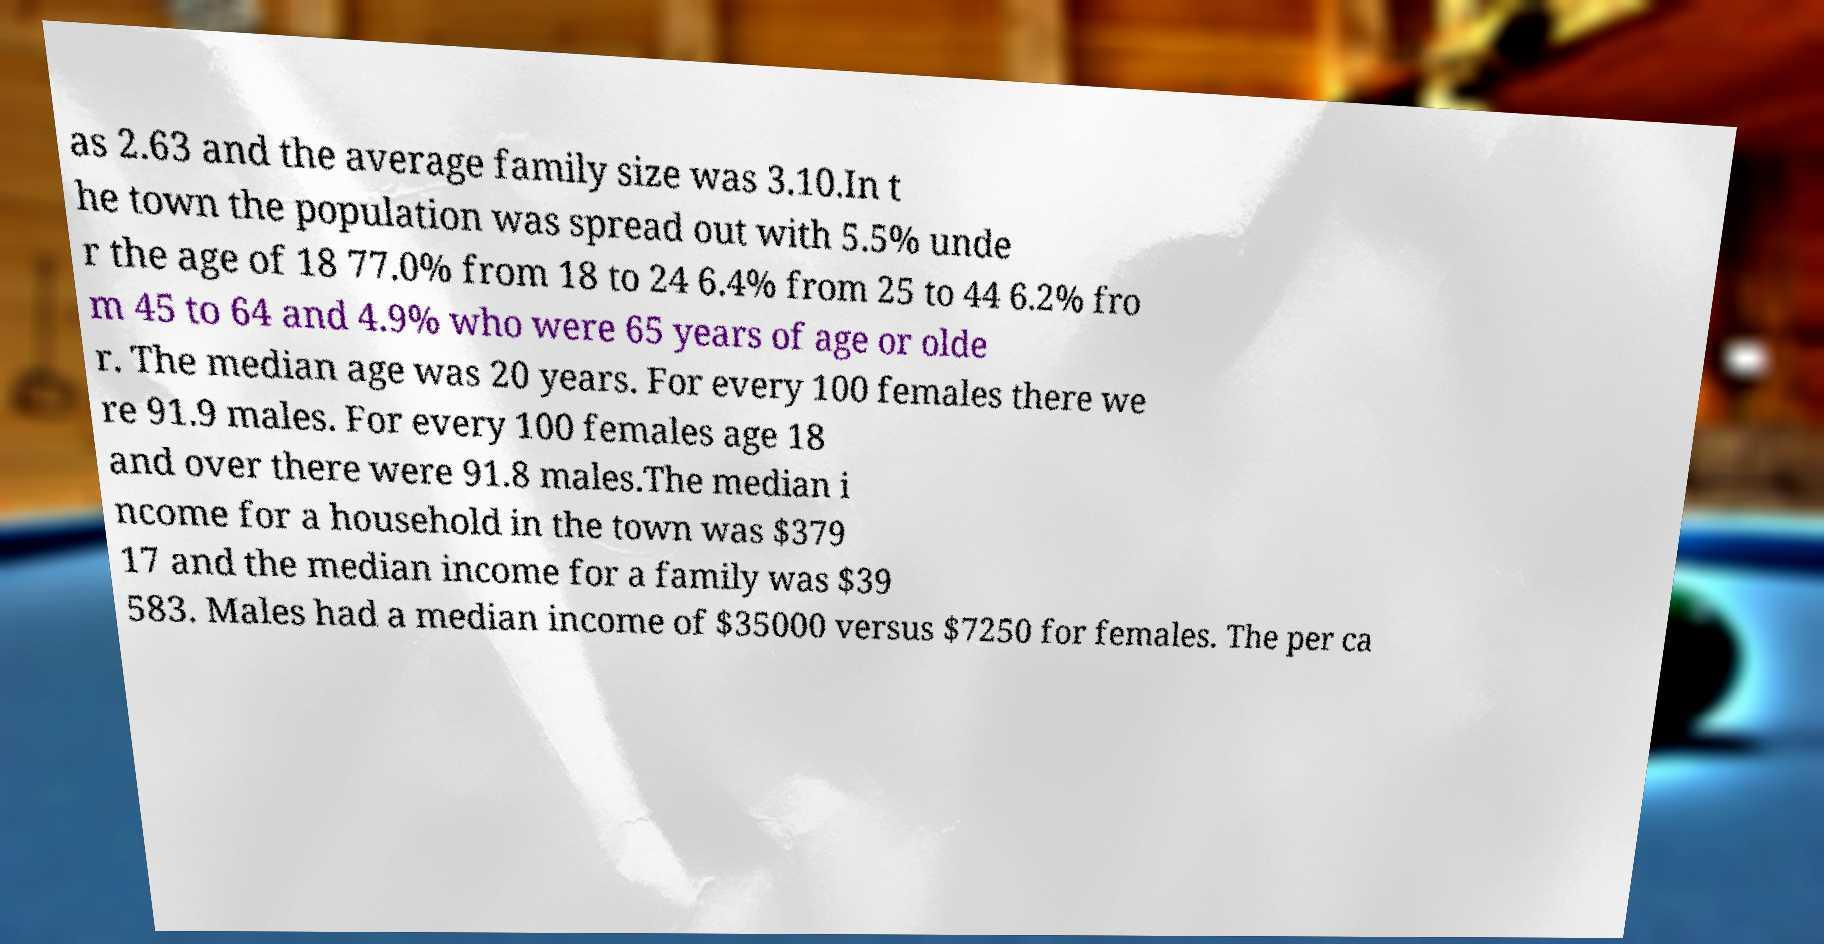Could you assist in decoding the text presented in this image and type it out clearly? as 2.63 and the average family size was 3.10.In t he town the population was spread out with 5.5% unde r the age of 18 77.0% from 18 to 24 6.4% from 25 to 44 6.2% fro m 45 to 64 and 4.9% who were 65 years of age or olde r. The median age was 20 years. For every 100 females there we re 91.9 males. For every 100 females age 18 and over there were 91.8 males.The median i ncome for a household in the town was $379 17 and the median income for a family was $39 583. Males had a median income of $35000 versus $7250 for females. The per ca 